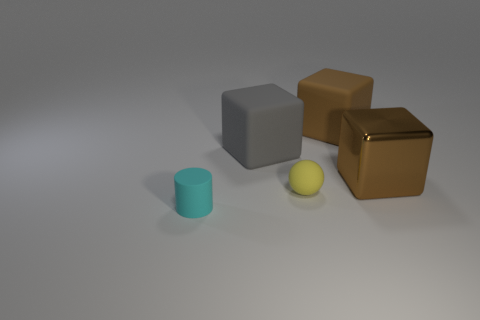Add 5 tiny brown rubber cylinders. How many objects exist? 10 Subtract all balls. How many objects are left? 4 Add 3 green cylinders. How many green cylinders exist? 3 Subtract 0 red blocks. How many objects are left? 5 Subtract all tiny brown shiny cubes. Subtract all big gray cubes. How many objects are left? 4 Add 5 tiny balls. How many tiny balls are left? 6 